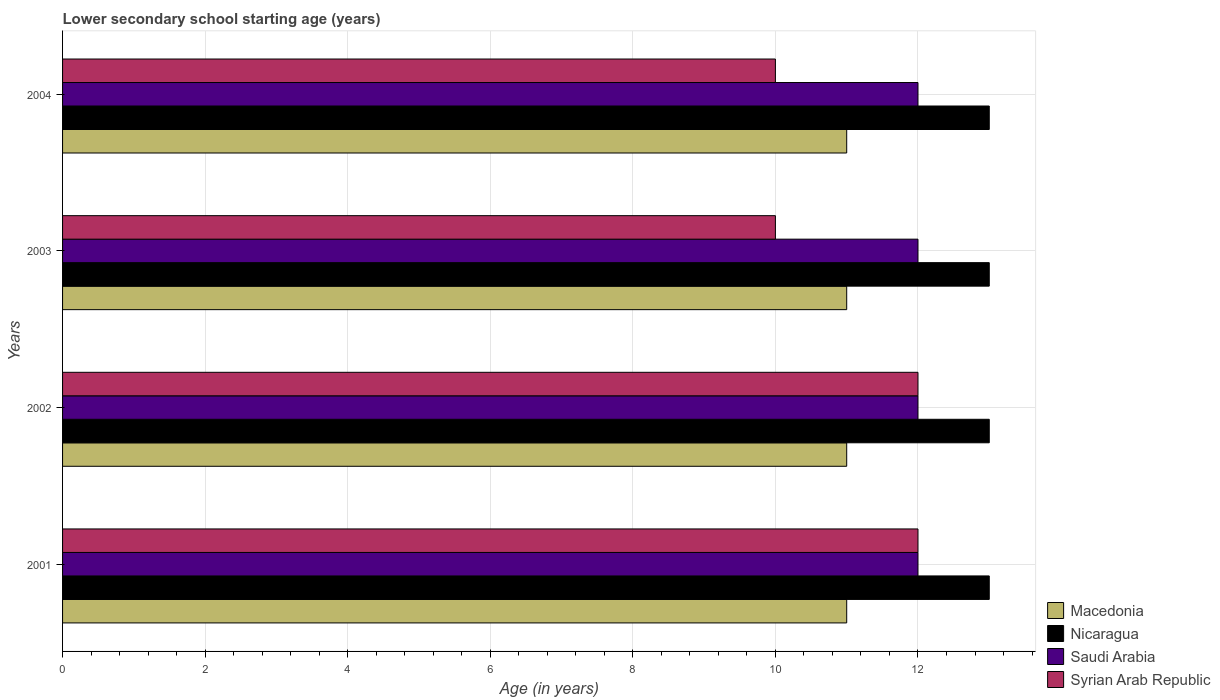How many groups of bars are there?
Give a very brief answer. 4. Are the number of bars per tick equal to the number of legend labels?
Offer a terse response. Yes. Are the number of bars on each tick of the Y-axis equal?
Your response must be concise. Yes. What is the lower secondary school starting age of children in Macedonia in 2001?
Provide a succinct answer. 11. Across all years, what is the maximum lower secondary school starting age of children in Syrian Arab Republic?
Offer a very short reply. 12. Across all years, what is the minimum lower secondary school starting age of children in Saudi Arabia?
Your answer should be very brief. 12. In which year was the lower secondary school starting age of children in Macedonia maximum?
Ensure brevity in your answer.  2001. What is the total lower secondary school starting age of children in Syrian Arab Republic in the graph?
Keep it short and to the point. 44. What is the difference between the lower secondary school starting age of children in Saudi Arabia in 2001 and that in 2003?
Your answer should be compact. 0. What is the difference between the lower secondary school starting age of children in Syrian Arab Republic in 2003 and the lower secondary school starting age of children in Saudi Arabia in 2002?
Give a very brief answer. -2. In the year 2004, what is the difference between the lower secondary school starting age of children in Saudi Arabia and lower secondary school starting age of children in Syrian Arab Republic?
Offer a terse response. 2. In how many years, is the lower secondary school starting age of children in Saudi Arabia greater than 9.2 years?
Your answer should be very brief. 4. Is the lower secondary school starting age of children in Saudi Arabia in 2001 less than that in 2002?
Give a very brief answer. No. What is the difference between the highest and the second highest lower secondary school starting age of children in Saudi Arabia?
Ensure brevity in your answer.  0. What is the difference between the highest and the lowest lower secondary school starting age of children in Macedonia?
Offer a terse response. 0. Is it the case that in every year, the sum of the lower secondary school starting age of children in Syrian Arab Republic and lower secondary school starting age of children in Macedonia is greater than the sum of lower secondary school starting age of children in Saudi Arabia and lower secondary school starting age of children in Nicaragua?
Your answer should be very brief. No. What does the 2nd bar from the top in 2003 represents?
Your response must be concise. Saudi Arabia. What does the 2nd bar from the bottom in 2004 represents?
Your answer should be very brief. Nicaragua. Is it the case that in every year, the sum of the lower secondary school starting age of children in Nicaragua and lower secondary school starting age of children in Macedonia is greater than the lower secondary school starting age of children in Syrian Arab Republic?
Provide a short and direct response. Yes. What is the difference between two consecutive major ticks on the X-axis?
Your response must be concise. 2. Does the graph contain any zero values?
Provide a succinct answer. No. What is the title of the graph?
Provide a succinct answer. Lower secondary school starting age (years). What is the label or title of the X-axis?
Your answer should be compact. Age (in years). What is the Age (in years) of Nicaragua in 2001?
Ensure brevity in your answer.  13. What is the Age (in years) of Saudi Arabia in 2001?
Your response must be concise. 12. What is the Age (in years) of Nicaragua in 2002?
Provide a succinct answer. 13. What is the Age (in years) in Macedonia in 2003?
Ensure brevity in your answer.  11. What is the Age (in years) in Saudi Arabia in 2003?
Make the answer very short. 12. What is the Age (in years) of Syrian Arab Republic in 2003?
Make the answer very short. 10. What is the Age (in years) in Macedonia in 2004?
Your answer should be compact. 11. What is the Age (in years) in Syrian Arab Republic in 2004?
Provide a succinct answer. 10. Across all years, what is the maximum Age (in years) of Macedonia?
Your response must be concise. 11. Across all years, what is the minimum Age (in years) in Nicaragua?
Ensure brevity in your answer.  13. Across all years, what is the minimum Age (in years) of Syrian Arab Republic?
Provide a short and direct response. 10. What is the total Age (in years) in Nicaragua in the graph?
Offer a very short reply. 52. What is the total Age (in years) in Syrian Arab Republic in the graph?
Provide a short and direct response. 44. What is the difference between the Age (in years) in Saudi Arabia in 2001 and that in 2002?
Your answer should be very brief. 0. What is the difference between the Age (in years) in Macedonia in 2001 and that in 2003?
Ensure brevity in your answer.  0. What is the difference between the Age (in years) in Nicaragua in 2001 and that in 2003?
Offer a terse response. 0. What is the difference between the Age (in years) of Nicaragua in 2001 and that in 2004?
Ensure brevity in your answer.  0. What is the difference between the Age (in years) in Saudi Arabia in 2001 and that in 2004?
Give a very brief answer. 0. What is the difference between the Age (in years) of Syrian Arab Republic in 2001 and that in 2004?
Provide a succinct answer. 2. What is the difference between the Age (in years) of Macedonia in 2002 and that in 2003?
Your response must be concise. 0. What is the difference between the Age (in years) of Saudi Arabia in 2002 and that in 2003?
Give a very brief answer. 0. What is the difference between the Age (in years) in Syrian Arab Republic in 2002 and that in 2003?
Your response must be concise. 2. What is the difference between the Age (in years) of Macedonia in 2002 and that in 2004?
Make the answer very short. 0. What is the difference between the Age (in years) of Saudi Arabia in 2002 and that in 2004?
Ensure brevity in your answer.  0. What is the difference between the Age (in years) in Syrian Arab Republic in 2002 and that in 2004?
Your answer should be compact. 2. What is the difference between the Age (in years) of Macedonia in 2003 and that in 2004?
Offer a very short reply. 0. What is the difference between the Age (in years) of Nicaragua in 2003 and that in 2004?
Ensure brevity in your answer.  0. What is the difference between the Age (in years) of Saudi Arabia in 2003 and that in 2004?
Your answer should be compact. 0. What is the difference between the Age (in years) in Syrian Arab Republic in 2003 and that in 2004?
Offer a very short reply. 0. What is the difference between the Age (in years) in Macedonia in 2001 and the Age (in years) in Nicaragua in 2002?
Keep it short and to the point. -2. What is the difference between the Age (in years) of Macedonia in 2001 and the Age (in years) of Saudi Arabia in 2002?
Offer a very short reply. -1. What is the difference between the Age (in years) of Saudi Arabia in 2001 and the Age (in years) of Syrian Arab Republic in 2002?
Your response must be concise. 0. What is the difference between the Age (in years) of Macedonia in 2001 and the Age (in years) of Saudi Arabia in 2003?
Make the answer very short. -1. What is the difference between the Age (in years) of Macedonia in 2001 and the Age (in years) of Syrian Arab Republic in 2003?
Make the answer very short. 1. What is the difference between the Age (in years) in Macedonia in 2001 and the Age (in years) in Saudi Arabia in 2004?
Ensure brevity in your answer.  -1. What is the difference between the Age (in years) in Macedonia in 2001 and the Age (in years) in Syrian Arab Republic in 2004?
Keep it short and to the point. 1. What is the difference between the Age (in years) of Saudi Arabia in 2001 and the Age (in years) of Syrian Arab Republic in 2004?
Your answer should be very brief. 2. What is the difference between the Age (in years) of Macedonia in 2002 and the Age (in years) of Saudi Arabia in 2003?
Give a very brief answer. -1. What is the difference between the Age (in years) in Macedonia in 2002 and the Age (in years) in Syrian Arab Republic in 2003?
Your answer should be very brief. 1. What is the difference between the Age (in years) of Saudi Arabia in 2002 and the Age (in years) of Syrian Arab Republic in 2003?
Offer a very short reply. 2. What is the difference between the Age (in years) of Nicaragua in 2002 and the Age (in years) of Syrian Arab Republic in 2004?
Your response must be concise. 3. What is the difference between the Age (in years) in Macedonia in 2003 and the Age (in years) in Saudi Arabia in 2004?
Give a very brief answer. -1. What is the difference between the Age (in years) of Macedonia in 2003 and the Age (in years) of Syrian Arab Republic in 2004?
Keep it short and to the point. 1. What is the difference between the Age (in years) in Saudi Arabia in 2003 and the Age (in years) in Syrian Arab Republic in 2004?
Offer a very short reply. 2. What is the average Age (in years) of Nicaragua per year?
Keep it short and to the point. 13. What is the average Age (in years) in Saudi Arabia per year?
Provide a short and direct response. 12. What is the average Age (in years) of Syrian Arab Republic per year?
Keep it short and to the point. 11. In the year 2001, what is the difference between the Age (in years) in Macedonia and Age (in years) in Saudi Arabia?
Offer a terse response. -1. In the year 2001, what is the difference between the Age (in years) of Macedonia and Age (in years) of Syrian Arab Republic?
Offer a very short reply. -1. In the year 2002, what is the difference between the Age (in years) in Macedonia and Age (in years) in Saudi Arabia?
Make the answer very short. -1. In the year 2002, what is the difference between the Age (in years) of Macedonia and Age (in years) of Syrian Arab Republic?
Give a very brief answer. -1. In the year 2002, what is the difference between the Age (in years) in Nicaragua and Age (in years) in Saudi Arabia?
Offer a terse response. 1. In the year 2002, what is the difference between the Age (in years) in Saudi Arabia and Age (in years) in Syrian Arab Republic?
Provide a succinct answer. 0. In the year 2004, what is the difference between the Age (in years) in Macedonia and Age (in years) in Nicaragua?
Provide a short and direct response. -2. In the year 2004, what is the difference between the Age (in years) of Macedonia and Age (in years) of Saudi Arabia?
Your answer should be very brief. -1. In the year 2004, what is the difference between the Age (in years) in Nicaragua and Age (in years) in Syrian Arab Republic?
Make the answer very short. 3. What is the ratio of the Age (in years) of Nicaragua in 2001 to that in 2002?
Your answer should be very brief. 1. What is the ratio of the Age (in years) in Syrian Arab Republic in 2001 to that in 2002?
Offer a very short reply. 1. What is the ratio of the Age (in years) in Macedonia in 2001 to that in 2003?
Keep it short and to the point. 1. What is the ratio of the Age (in years) of Nicaragua in 2001 to that in 2003?
Your response must be concise. 1. What is the ratio of the Age (in years) of Saudi Arabia in 2001 to that in 2003?
Ensure brevity in your answer.  1. What is the ratio of the Age (in years) of Macedonia in 2002 to that in 2004?
Provide a succinct answer. 1. What is the ratio of the Age (in years) in Nicaragua in 2002 to that in 2004?
Offer a terse response. 1. What is the ratio of the Age (in years) in Syrian Arab Republic in 2002 to that in 2004?
Provide a short and direct response. 1.2. What is the ratio of the Age (in years) of Macedonia in 2003 to that in 2004?
Provide a short and direct response. 1. What is the ratio of the Age (in years) of Syrian Arab Republic in 2003 to that in 2004?
Offer a very short reply. 1. What is the difference between the highest and the second highest Age (in years) of Macedonia?
Offer a very short reply. 0. What is the difference between the highest and the second highest Age (in years) in Saudi Arabia?
Make the answer very short. 0. What is the difference between the highest and the second highest Age (in years) in Syrian Arab Republic?
Ensure brevity in your answer.  0. What is the difference between the highest and the lowest Age (in years) of Nicaragua?
Offer a very short reply. 0. What is the difference between the highest and the lowest Age (in years) in Saudi Arabia?
Provide a succinct answer. 0. 